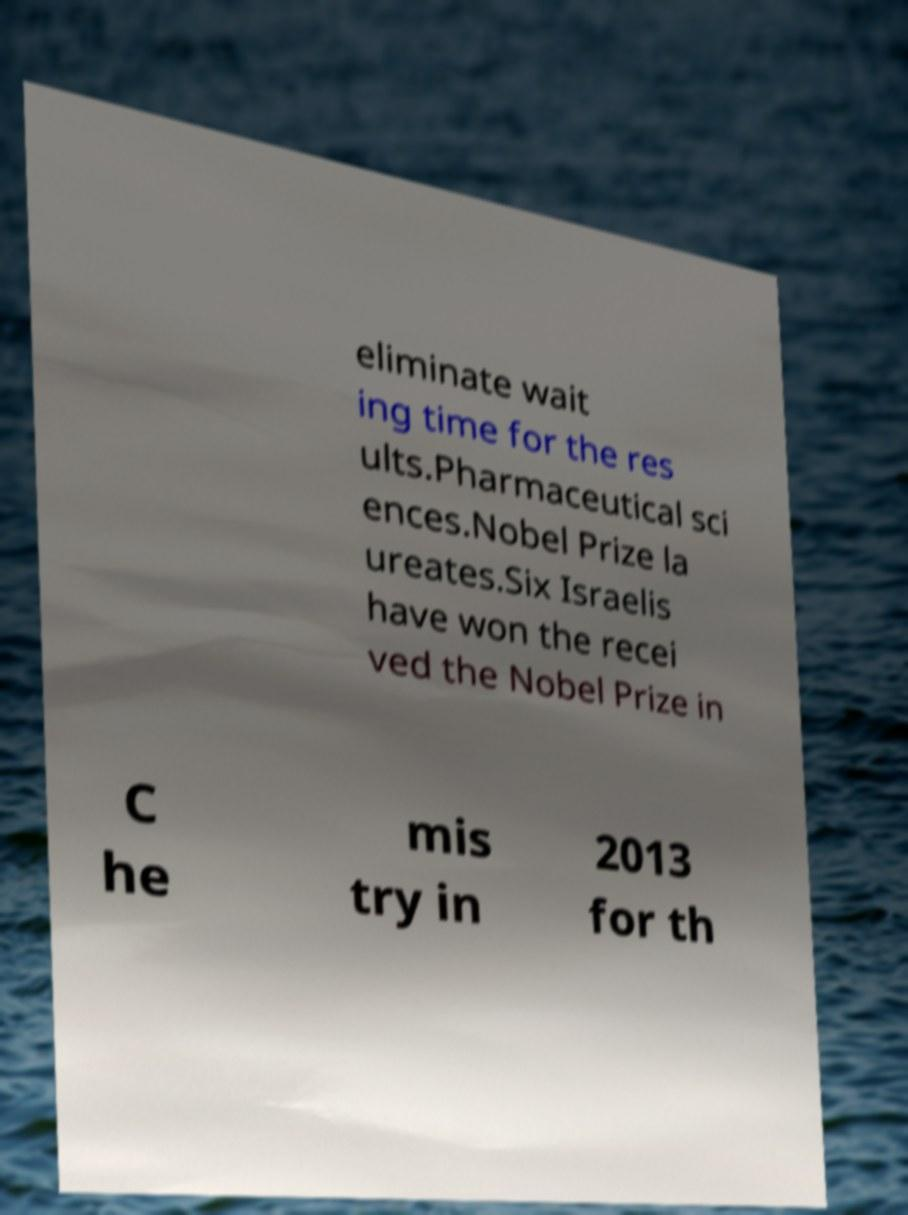Could you assist in decoding the text presented in this image and type it out clearly? eliminate wait ing time for the res ults.Pharmaceutical sci ences.Nobel Prize la ureates.Six Israelis have won the recei ved the Nobel Prize in C he mis try in 2013 for th 